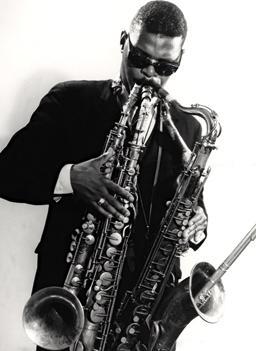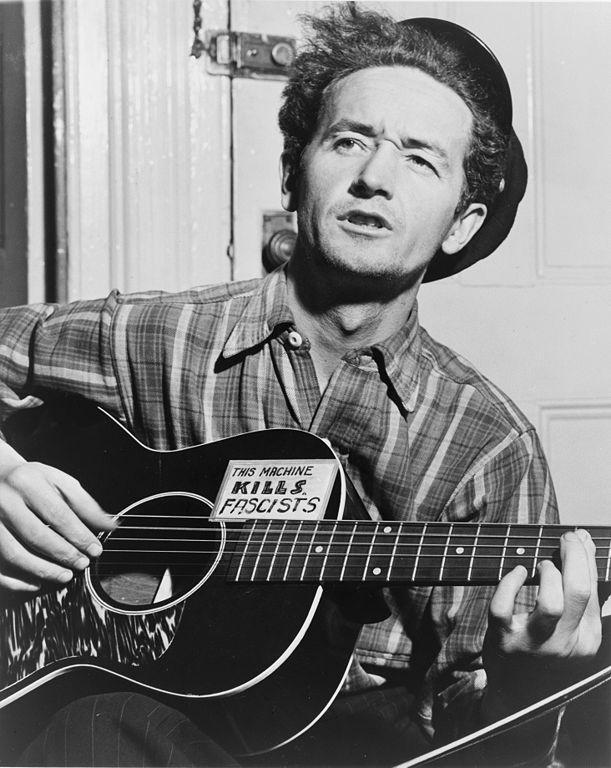The first image is the image on the left, the second image is the image on the right. Examine the images to the left and right. Is the description "In one of the image there is a man playing a guitar in his lap." accurate? Answer yes or no. Yes. The first image is the image on the left, the second image is the image on the right. Examine the images to the left and right. Is the description "A musician is holding a guitar in the right image." accurate? Answer yes or no. Yes. 